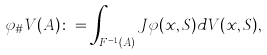Convert formula to latex. <formula><loc_0><loc_0><loc_500><loc_500>\varphi _ { \# } V ( A ) \colon = \int _ { F ^ { - 1 } ( A ) } J \varphi ( x , S ) d V ( x , S ) ,</formula> 